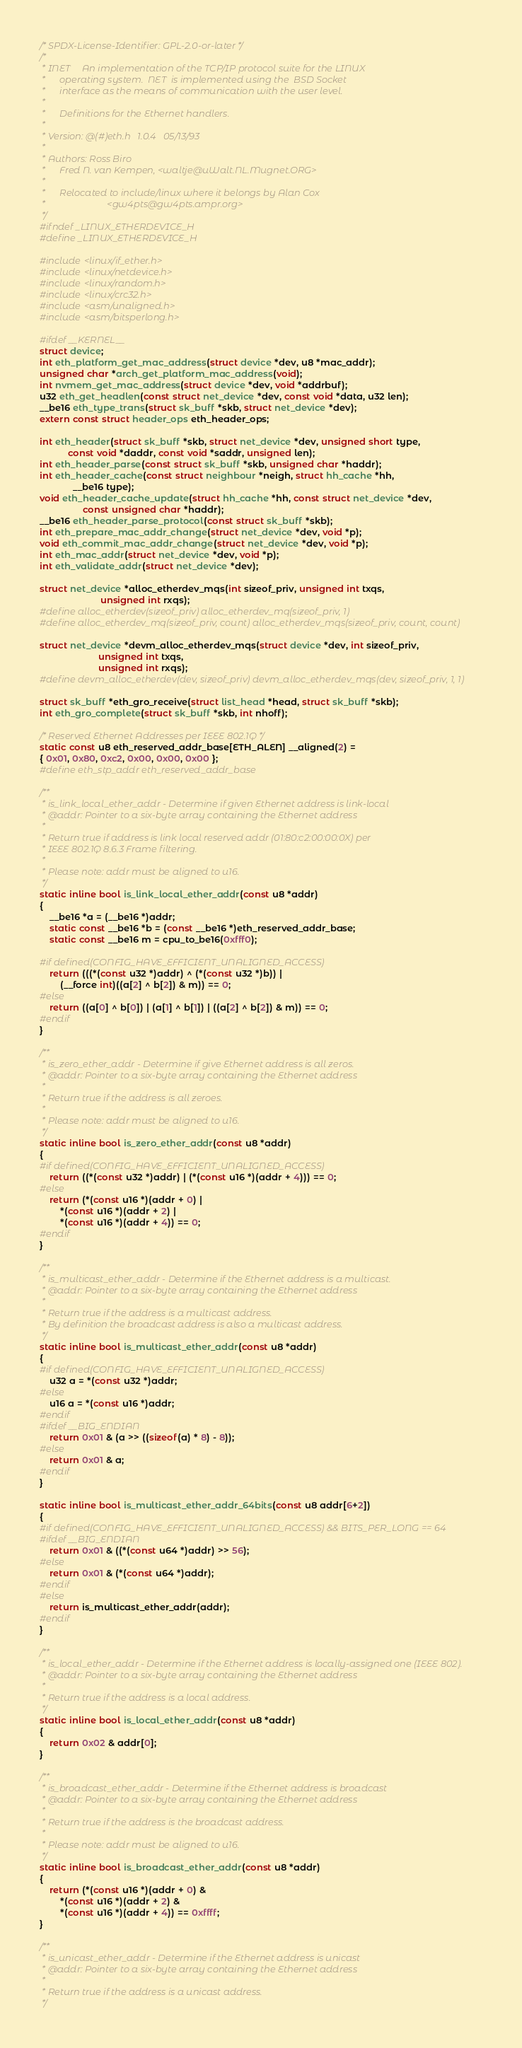Convert code to text. <code><loc_0><loc_0><loc_500><loc_500><_C_>/* SPDX-License-Identifier: GPL-2.0-or-later */
/*
 * INET		An implementation of the TCP/IP protocol suite for the LINUX
 *		operating system.  NET  is implemented using the  BSD Socket
 *		interface as the means of communication with the user level.
 *
 *		Definitions for the Ethernet handlers.
 *
 * Version:	@(#)eth.h	1.0.4	05/13/93
 *
 * Authors:	Ross Biro
 *		Fred N. van Kempen, <waltje@uWalt.NL.Mugnet.ORG>
 *
 *		Relocated to include/linux where it belongs by Alan Cox
 *							<gw4pts@gw4pts.ampr.org>
 */
#ifndef _LINUX_ETHERDEVICE_H
#define _LINUX_ETHERDEVICE_H

#include <linux/if_ether.h>
#include <linux/netdevice.h>
#include <linux/random.h>
#include <linux/crc32.h>
#include <asm/unaligned.h>
#include <asm/bitsperlong.h>

#ifdef __KERNEL__
struct device;
int eth_platform_get_mac_address(struct device *dev, u8 *mac_addr);
unsigned char *arch_get_platform_mac_address(void);
int nvmem_get_mac_address(struct device *dev, void *addrbuf);
u32 eth_get_headlen(const struct net_device *dev, const void *data, u32 len);
__be16 eth_type_trans(struct sk_buff *skb, struct net_device *dev);
extern const struct header_ops eth_header_ops;

int eth_header(struct sk_buff *skb, struct net_device *dev, unsigned short type,
	       const void *daddr, const void *saddr, unsigned len);
int eth_header_parse(const struct sk_buff *skb, unsigned char *haddr);
int eth_header_cache(const struct neighbour *neigh, struct hh_cache *hh,
		     __be16 type);
void eth_header_cache_update(struct hh_cache *hh, const struct net_device *dev,
			     const unsigned char *haddr);
__be16 eth_header_parse_protocol(const struct sk_buff *skb);
int eth_prepare_mac_addr_change(struct net_device *dev, void *p);
void eth_commit_mac_addr_change(struct net_device *dev, void *p);
int eth_mac_addr(struct net_device *dev, void *p);
int eth_validate_addr(struct net_device *dev);

struct net_device *alloc_etherdev_mqs(int sizeof_priv, unsigned int txqs,
					    unsigned int rxqs);
#define alloc_etherdev(sizeof_priv) alloc_etherdev_mq(sizeof_priv, 1)
#define alloc_etherdev_mq(sizeof_priv, count) alloc_etherdev_mqs(sizeof_priv, count, count)

struct net_device *devm_alloc_etherdev_mqs(struct device *dev, int sizeof_priv,
					   unsigned int txqs,
					   unsigned int rxqs);
#define devm_alloc_etherdev(dev, sizeof_priv) devm_alloc_etherdev_mqs(dev, sizeof_priv, 1, 1)

struct sk_buff *eth_gro_receive(struct list_head *head, struct sk_buff *skb);
int eth_gro_complete(struct sk_buff *skb, int nhoff);

/* Reserved Ethernet Addresses per IEEE 802.1Q */
static const u8 eth_reserved_addr_base[ETH_ALEN] __aligned(2) =
{ 0x01, 0x80, 0xc2, 0x00, 0x00, 0x00 };
#define eth_stp_addr eth_reserved_addr_base

/**
 * is_link_local_ether_addr - Determine if given Ethernet address is link-local
 * @addr: Pointer to a six-byte array containing the Ethernet address
 *
 * Return true if address is link local reserved addr (01:80:c2:00:00:0X) per
 * IEEE 802.1Q 8.6.3 Frame filtering.
 *
 * Please note: addr must be aligned to u16.
 */
static inline bool is_link_local_ether_addr(const u8 *addr)
{
	__be16 *a = (__be16 *)addr;
	static const __be16 *b = (const __be16 *)eth_reserved_addr_base;
	static const __be16 m = cpu_to_be16(0xfff0);

#if defined(CONFIG_HAVE_EFFICIENT_UNALIGNED_ACCESS)
	return (((*(const u32 *)addr) ^ (*(const u32 *)b)) |
		(__force int)((a[2] ^ b[2]) & m)) == 0;
#else
	return ((a[0] ^ b[0]) | (a[1] ^ b[1]) | ((a[2] ^ b[2]) & m)) == 0;
#endif
}

/**
 * is_zero_ether_addr - Determine if give Ethernet address is all zeros.
 * @addr: Pointer to a six-byte array containing the Ethernet address
 *
 * Return true if the address is all zeroes.
 *
 * Please note: addr must be aligned to u16.
 */
static inline bool is_zero_ether_addr(const u8 *addr)
{
#if defined(CONFIG_HAVE_EFFICIENT_UNALIGNED_ACCESS)
	return ((*(const u32 *)addr) | (*(const u16 *)(addr + 4))) == 0;
#else
	return (*(const u16 *)(addr + 0) |
		*(const u16 *)(addr + 2) |
		*(const u16 *)(addr + 4)) == 0;
#endif
}

/**
 * is_multicast_ether_addr - Determine if the Ethernet address is a multicast.
 * @addr: Pointer to a six-byte array containing the Ethernet address
 *
 * Return true if the address is a multicast address.
 * By definition the broadcast address is also a multicast address.
 */
static inline bool is_multicast_ether_addr(const u8 *addr)
{
#if defined(CONFIG_HAVE_EFFICIENT_UNALIGNED_ACCESS)
	u32 a = *(const u32 *)addr;
#else
	u16 a = *(const u16 *)addr;
#endif
#ifdef __BIG_ENDIAN
	return 0x01 & (a >> ((sizeof(a) * 8) - 8));
#else
	return 0x01 & a;
#endif
}

static inline bool is_multicast_ether_addr_64bits(const u8 addr[6+2])
{
#if defined(CONFIG_HAVE_EFFICIENT_UNALIGNED_ACCESS) && BITS_PER_LONG == 64
#ifdef __BIG_ENDIAN
	return 0x01 & ((*(const u64 *)addr) >> 56);
#else
	return 0x01 & (*(const u64 *)addr);
#endif
#else
	return is_multicast_ether_addr(addr);
#endif
}

/**
 * is_local_ether_addr - Determine if the Ethernet address is locally-assigned one (IEEE 802).
 * @addr: Pointer to a six-byte array containing the Ethernet address
 *
 * Return true if the address is a local address.
 */
static inline bool is_local_ether_addr(const u8 *addr)
{
	return 0x02 & addr[0];
}

/**
 * is_broadcast_ether_addr - Determine if the Ethernet address is broadcast
 * @addr: Pointer to a six-byte array containing the Ethernet address
 *
 * Return true if the address is the broadcast address.
 *
 * Please note: addr must be aligned to u16.
 */
static inline bool is_broadcast_ether_addr(const u8 *addr)
{
	return (*(const u16 *)(addr + 0) &
		*(const u16 *)(addr + 2) &
		*(const u16 *)(addr + 4)) == 0xffff;
}

/**
 * is_unicast_ether_addr - Determine if the Ethernet address is unicast
 * @addr: Pointer to a six-byte array containing the Ethernet address
 *
 * Return true if the address is a unicast address.
 */</code> 